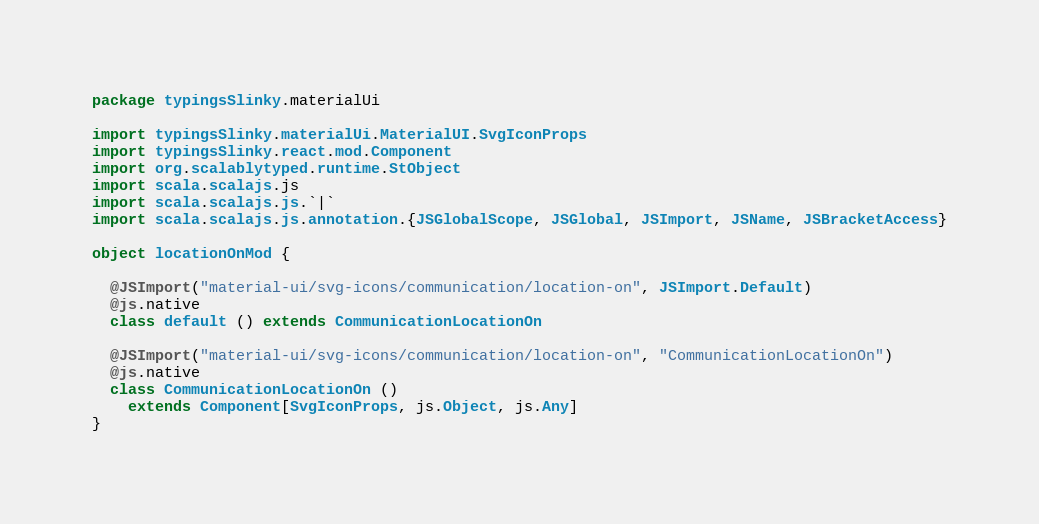Convert code to text. <code><loc_0><loc_0><loc_500><loc_500><_Scala_>package typingsSlinky.materialUi

import typingsSlinky.materialUi.MaterialUI.SvgIconProps
import typingsSlinky.react.mod.Component
import org.scalablytyped.runtime.StObject
import scala.scalajs.js
import scala.scalajs.js.`|`
import scala.scalajs.js.annotation.{JSGlobalScope, JSGlobal, JSImport, JSName, JSBracketAccess}

object locationOnMod {
  
  @JSImport("material-ui/svg-icons/communication/location-on", JSImport.Default)
  @js.native
  class default () extends CommunicationLocationOn
  
  @JSImport("material-ui/svg-icons/communication/location-on", "CommunicationLocationOn")
  @js.native
  class CommunicationLocationOn ()
    extends Component[SvgIconProps, js.Object, js.Any]
}
</code> 